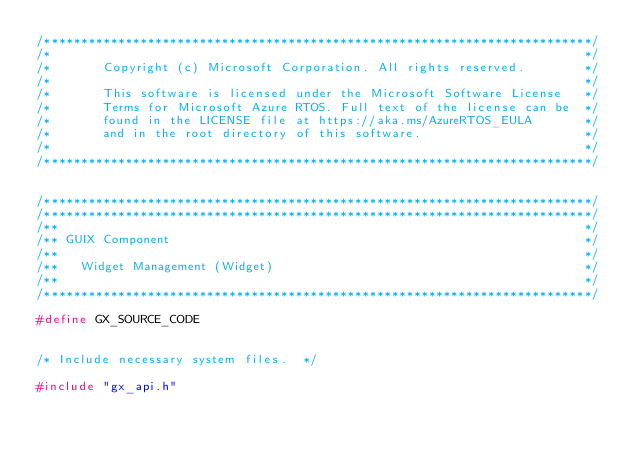Convert code to text. <code><loc_0><loc_0><loc_500><loc_500><_C_>/**************************************************************************/
/*                                                                        */
/*       Copyright (c) Microsoft Corporation. All rights reserved.        */
/*                                                                        */
/*       This software is licensed under the Microsoft Software License   */
/*       Terms for Microsoft Azure RTOS. Full text of the license can be  */
/*       found in the LICENSE file at https://aka.ms/AzureRTOS_EULA       */
/*       and in the root directory of this software.                      */
/*                                                                        */
/**************************************************************************/


/**************************************************************************/
/**************************************************************************/
/**                                                                       */
/** GUIX Component                                                        */
/**                                                                       */
/**   Widget Management (Widget)                                          */
/**                                                                       */
/**************************************************************************/

#define GX_SOURCE_CODE


/* Include necessary system files.  */

#include "gx_api.h"</code> 